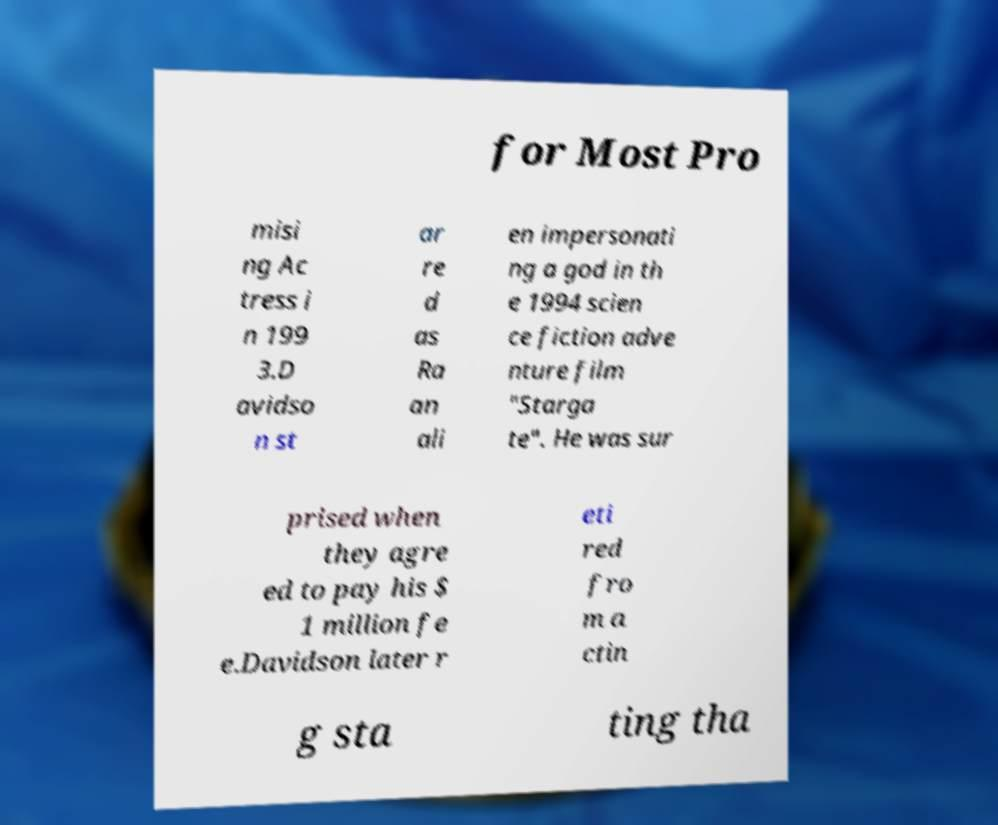Could you assist in decoding the text presented in this image and type it out clearly? for Most Pro misi ng Ac tress i n 199 3.D avidso n st ar re d as Ra an ali en impersonati ng a god in th e 1994 scien ce fiction adve nture film "Starga te". He was sur prised when they agre ed to pay his $ 1 million fe e.Davidson later r eti red fro m a ctin g sta ting tha 